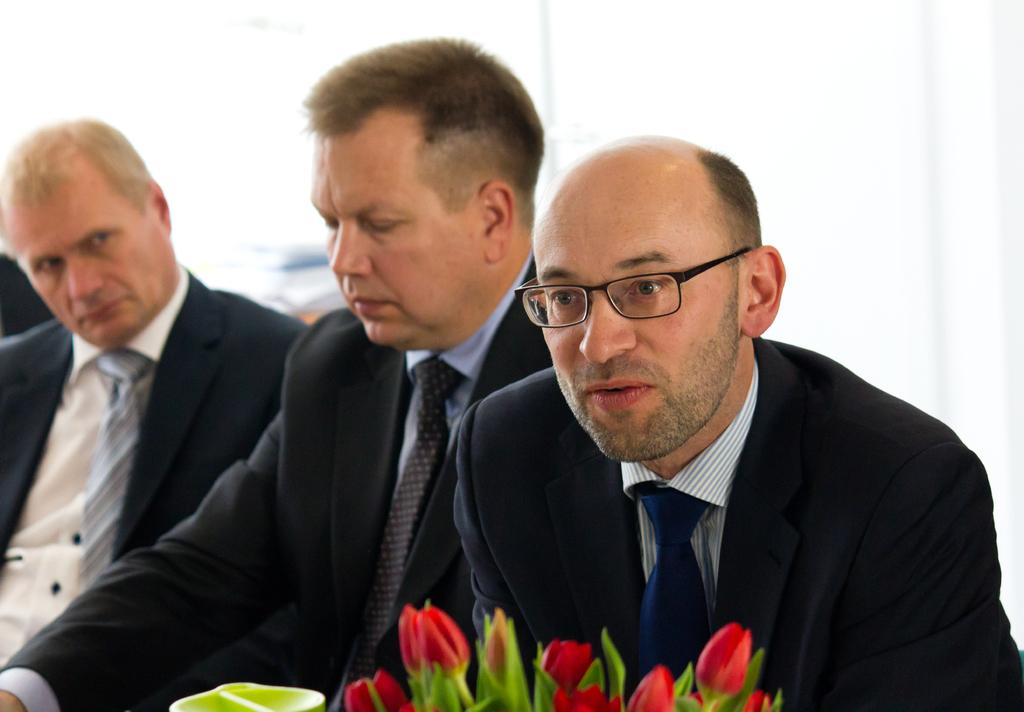How many people are in the image? There are three men in the image. What are the men wearing? All three men are wearing coats. Can you describe any accessories worn by the men? One of the men is wearing spectacles. What can be seen at the bottom of the image? There are flowers visible at the bottom of the image. What type of chain is the dad holding in the image? There is no dad or chain present in the image. How many fingers does the man with spectacles have on his right hand? The image does not show the number of fingers on the man's hand, as it only provides a general view of the men wearing coats. 